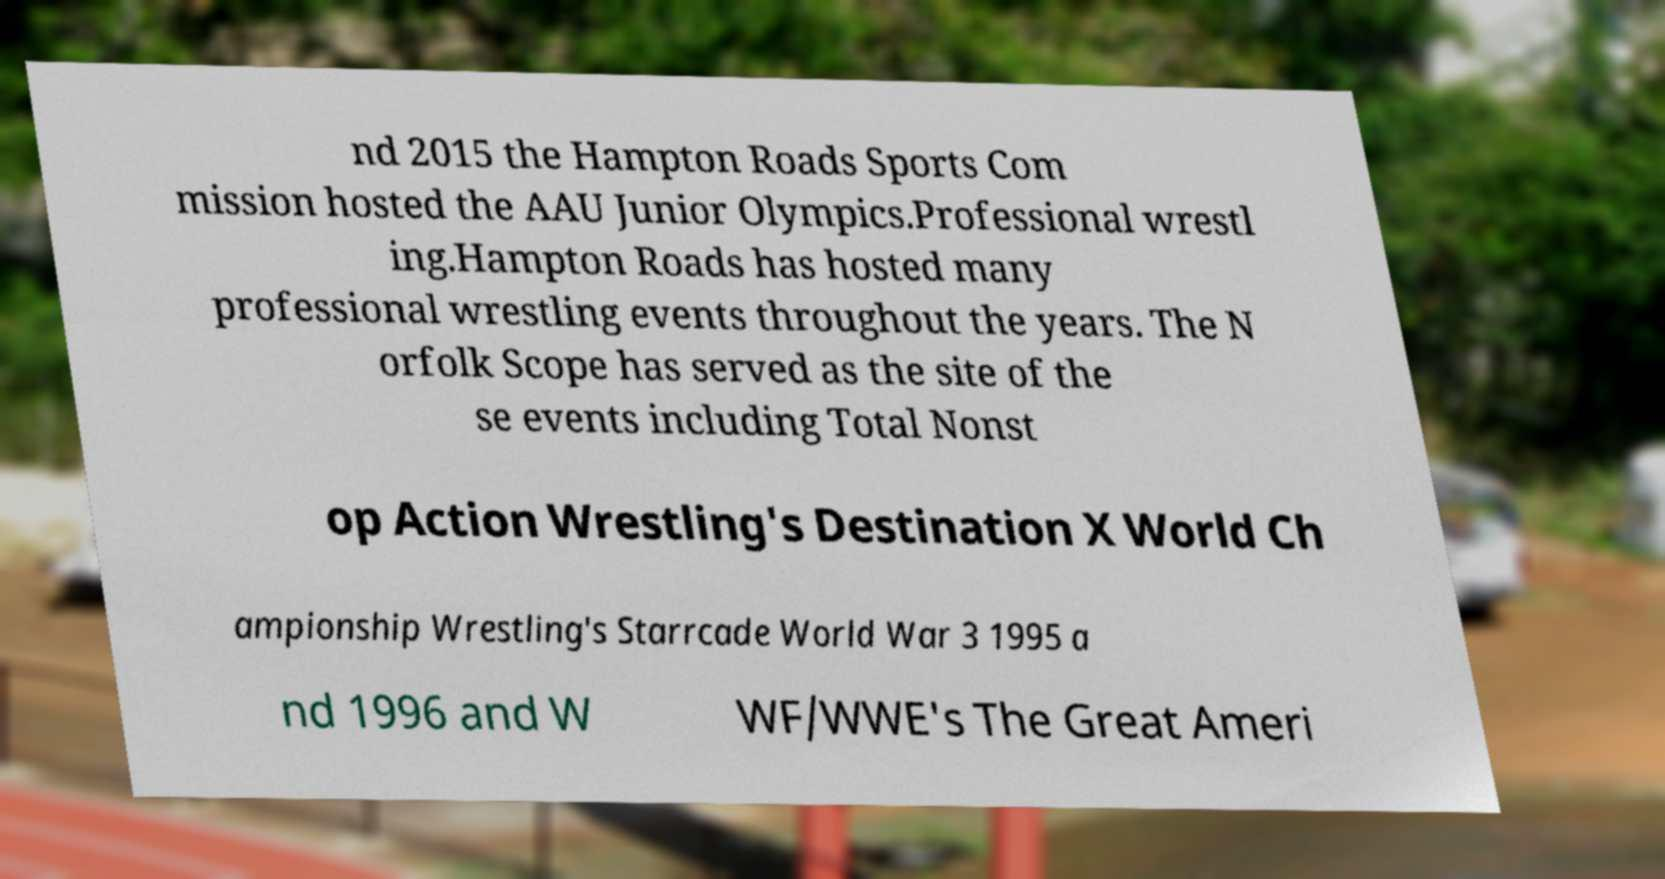Can you accurately transcribe the text from the provided image for me? nd 2015 the Hampton Roads Sports Com mission hosted the AAU Junior Olympics.Professional wrestl ing.Hampton Roads has hosted many professional wrestling events throughout the years. The N orfolk Scope has served as the site of the se events including Total Nonst op Action Wrestling's Destination X World Ch ampionship Wrestling's Starrcade World War 3 1995 a nd 1996 and W WF/WWE's The Great Ameri 